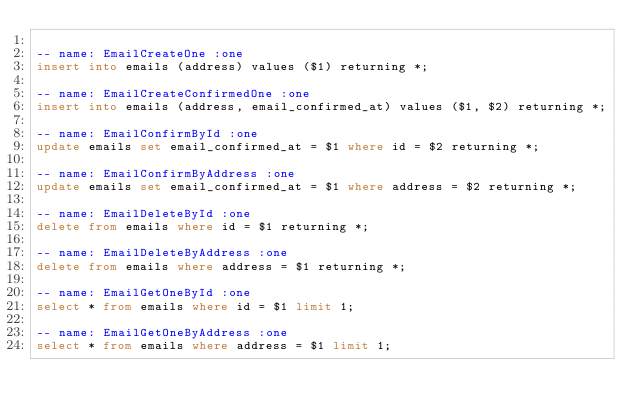<code> <loc_0><loc_0><loc_500><loc_500><_SQL_>
-- name: EmailCreateOne :one
insert into emails (address) values ($1) returning *;

-- name: EmailCreateConfirmedOne :one
insert into emails (address, email_confirmed_at) values ($1, $2) returning *;

-- name: EmailConfirmById :one
update emails set email_confirmed_at = $1 where id = $2 returning *;

-- name: EmailConfirmByAddress :one
update emails set email_confirmed_at = $1 where address = $2 returning *;

-- name: EmailDeleteById :one
delete from emails where id = $1 returning *;

-- name: EmailDeleteByAddress :one
delete from emails where address = $1 returning *;

-- name: EmailGetOneById :one
select * from emails where id = $1 limit 1;

-- name: EmailGetOneByAddress :one
select * from emails where address = $1 limit 1;
</code> 